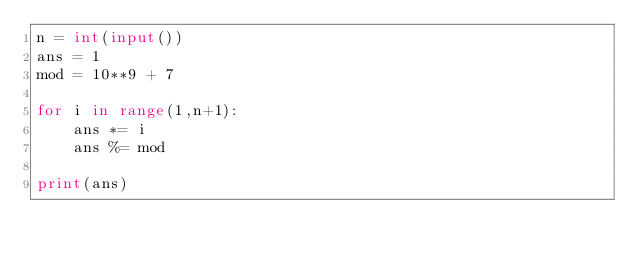Convert code to text. <code><loc_0><loc_0><loc_500><loc_500><_Python_>n = int(input())
ans = 1
mod = 10**9 + 7

for i in range(1,n+1):
    ans *= i
    ans %= mod
    
print(ans)</code> 